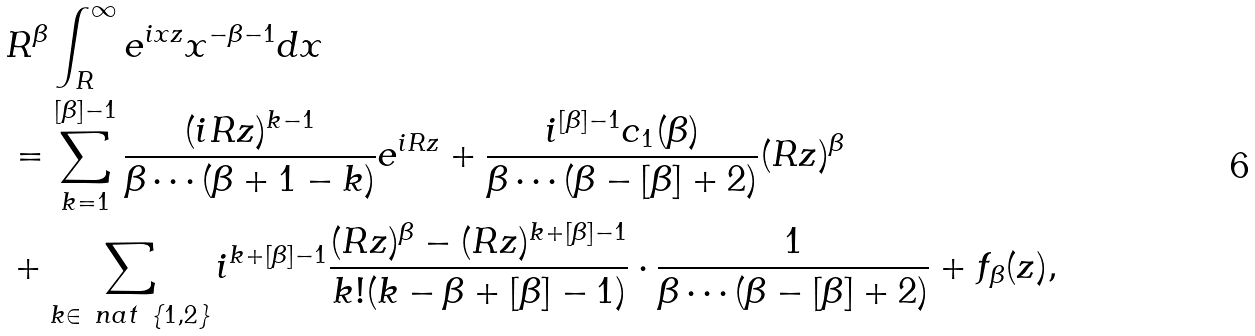Convert formula to latex. <formula><loc_0><loc_0><loc_500><loc_500>& R ^ { \beta } \int _ { R } ^ { \infty } e ^ { i x z } x ^ { - \beta - 1 } d x \\ & = \sum _ { k = 1 } ^ { [ \beta ] - 1 } \frac { ( i R z ) ^ { k - 1 } } { \beta \cdots ( \beta + 1 - k ) } e ^ { i R z } + \frac { i ^ { [ \beta ] - 1 } c _ { 1 } ( \beta ) } { \beta \cdots ( \beta - [ \beta ] + 2 ) } ( R z ) ^ { \beta } \\ & + \sum _ { k \in \ n a t \ \{ 1 , 2 \} } i ^ { k + [ \beta ] - 1 } \frac { ( R z ) ^ { \beta } - ( R z ) ^ { k + [ \beta ] - 1 } } { k ! ( k - \beta + [ \beta ] - 1 ) } \cdot \frac { 1 } { \beta \cdots ( \beta - [ \beta ] + 2 ) } + f _ { \beta } ( z ) ,</formula> 